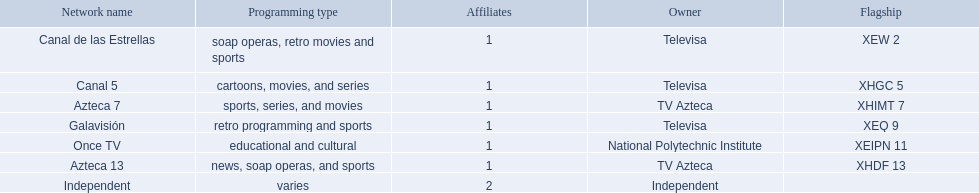What stations show sports? Soap operas, retro movies and sports, retro programming and sports, news, soap operas, and sports. What of these is not affiliated with televisa? Azteca 7. 